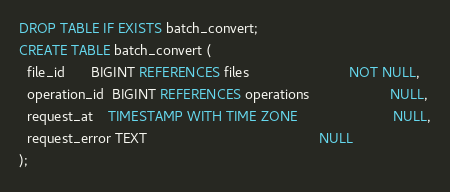<code> <loc_0><loc_0><loc_500><loc_500><_SQL_>

DROP TABLE IF EXISTS batch_convert;
CREATE TABLE batch_convert (
  file_id       BIGINT REFERENCES files                          NOT NULL,
  operation_id  BIGINT REFERENCES operations                     NULL,
  request_at    TIMESTAMP WITH TIME ZONE                         NULL,
  request_error TEXT                                             NULL
);</code> 